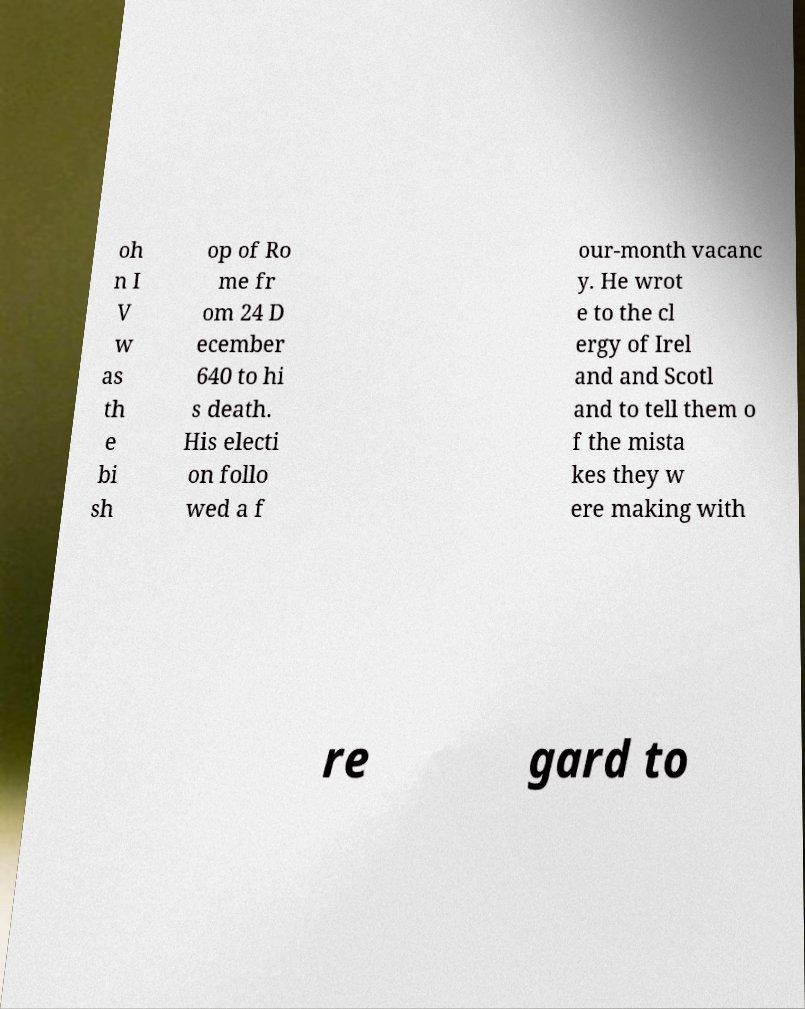Please identify and transcribe the text found in this image. oh n I V w as th e bi sh op of Ro me fr om 24 D ecember 640 to hi s death. His electi on follo wed a f our-month vacanc y. He wrot e to the cl ergy of Irel and and Scotl and to tell them o f the mista kes they w ere making with re gard to 